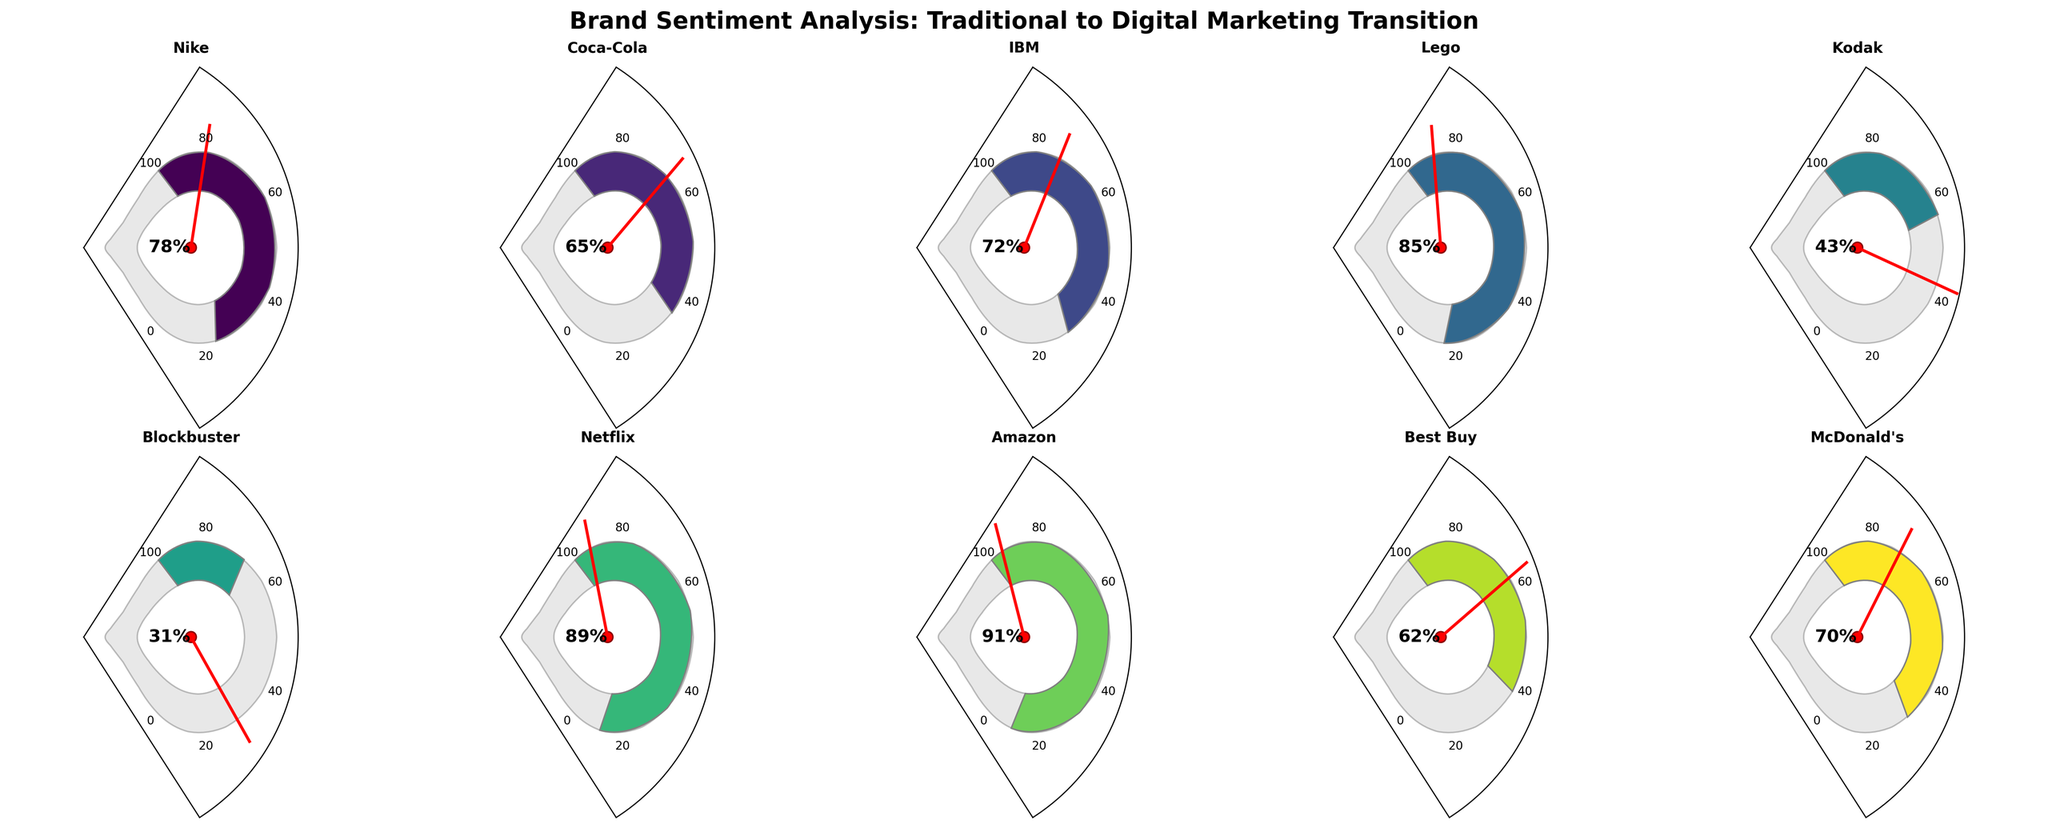What's the title of the figure? The title of the figure is displayed prominently at the top. Since the question is about basic visual elements, the title can be directly read from the chart.
Answer: Brand Sentiment Analysis: Traditional to Digital Marketing Transition How many companies have a sentiment score above 80? To solve this, look at each gauge and count the number of companies with sentiment scores above 80. These gauges will show scores higher than the 80% mark on the scale. Companies with scores above 80 are Lego, Netflix, and Amazon, making it three companies.
Answer: 3 Which company has the lowest sentiment score and what is it? Examine all gauges and identify the company with the needle pointing to the lowest percentage. The lowest sentiment score, 31%, belongs to Blockbuster.
Answer: Blockbuster, 31% Compare the sentiment scores of Lego and Kodak. Which one is higher and by how much? Find both Lego and Kodak on their respective gauges. Lego has a sentiment score of 85% and Kodak has 43%. Subtract Kodak's score from Lego's to find the difference. 85 - 43 = 42, so Lego's score is 42% higher.
Answer: Lego, 42% What is the average sentiment score across all the companies? Add all the sentiment scores: 78 + 65 + 72 + 85 + 43 + 31 + 89 + 91 + 62 + 70 = 686. Then, divide the sum by the number of companies, which is 10. Thus, the average score is 686 / 10 = 68.6
Answer: 68.6 Between Coca-Cola and McDonald's, which company has a better sentiment score? Compare the sentiment scores of Coca-Cola and McDonald's. Coca-Cola has a score of 65, while McDonald's has a score of 70. McDonald's score is higher.
Answer: McDonald's Which company has the second-highest sentiment score? Identify the highest score first, which is Amazon with 91%. Then, find the next highest score, which is Netflix with 89%.
Answer: Netflix Are there more companies with sentiment scores above or below 70? Count the companies above 70: Nike (78), IBM (72), Lego (85), Netflix (89), and Amazon (91) = 5 companies. Now, count the companies below 70: Coca-Cola (65), Kodak (43), Blockbuster (31), Best Buy (62), and McDonald's (70 does not count as it's equal, not below) = 4 companies. More companies have scores above 70.
Answer: Above What is the combined sentiment score of Nike, IBM, and McDonald's? Add the sentiment scores of Nike (78), IBM (72), and McDonald's (70). 78 + 72 + 70 = 220
Answer: 220 What is the median sentiment score of all the companies listed? First, sort the sentiment scores: 31, 43, 62, 65, 70, 72, 78, 85, 89, 91. The median score is the middle value in this sorted list. Since there are 10 values, the median is the average of the 5th and 6th values: (70 + 72) / 2 = 71
Answer: 71 